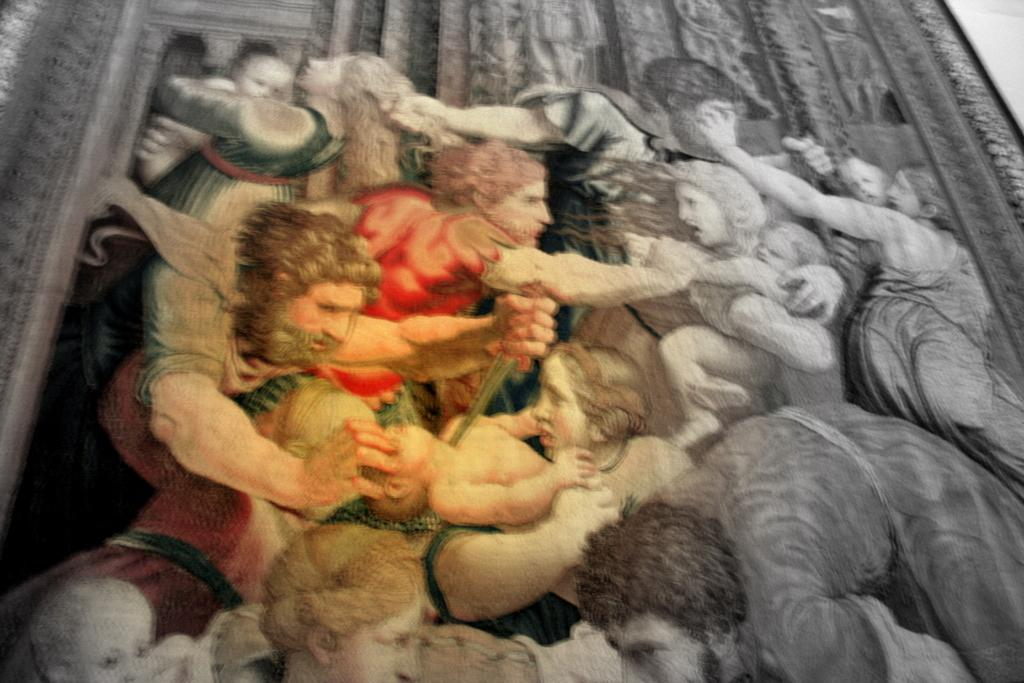What is the color scheme of the picture? The picture is black and white. What can be seen on the wall in the image? There is a picture frame on the wall. What is depicted within the picture frame? The picture frame contains paintings of people. Is there any color present in the picture frame? Yes, there is a colored print in the center of the frame. How much glue is needed to attach the pocket to the wall in the image? There is no pocket present in the image, so it is not possible to determine how much glue would be needed. 